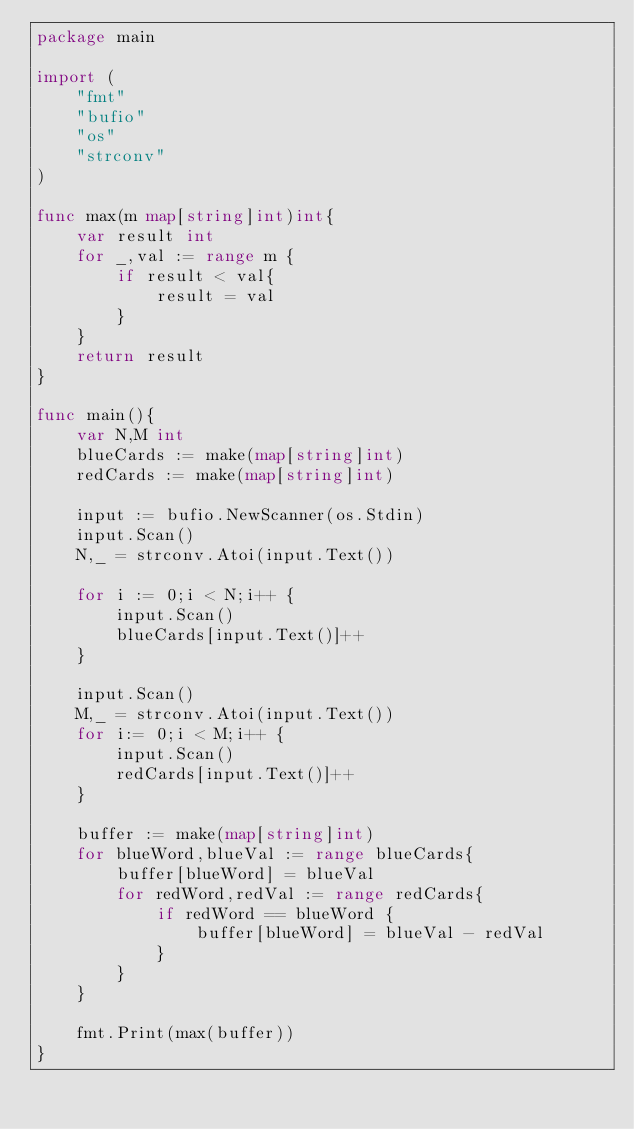<code> <loc_0><loc_0><loc_500><loc_500><_Go_>package main

import (
	"fmt"
	"bufio"
	"os"
	"strconv"
)

func max(m map[string]int)int{
	var result int
	for _,val := range m {
		if result < val{
			result = val
		}
	}
	return result
}

func main(){
	var N,M int
	blueCards := make(map[string]int)
	redCards := make(map[string]int)

	input := bufio.NewScanner(os.Stdin)
	input.Scan()
	N,_ = strconv.Atoi(input.Text())

	for i := 0;i < N;i++ {
		input.Scan()
		blueCards[input.Text()]++
	}

	input.Scan()
	M,_ = strconv.Atoi(input.Text())
	for i:= 0;i < M;i++ {
		input.Scan()
		redCards[input.Text()]++
	}
	
	buffer := make(map[string]int)
	for blueWord,blueVal := range blueCards{
		buffer[blueWord] = blueVal
		for redWord,redVal := range redCards{
			if redWord == blueWord {
				buffer[blueWord] = blueVal - redVal
			}
		}
	}

	fmt.Print(max(buffer))
}

</code> 